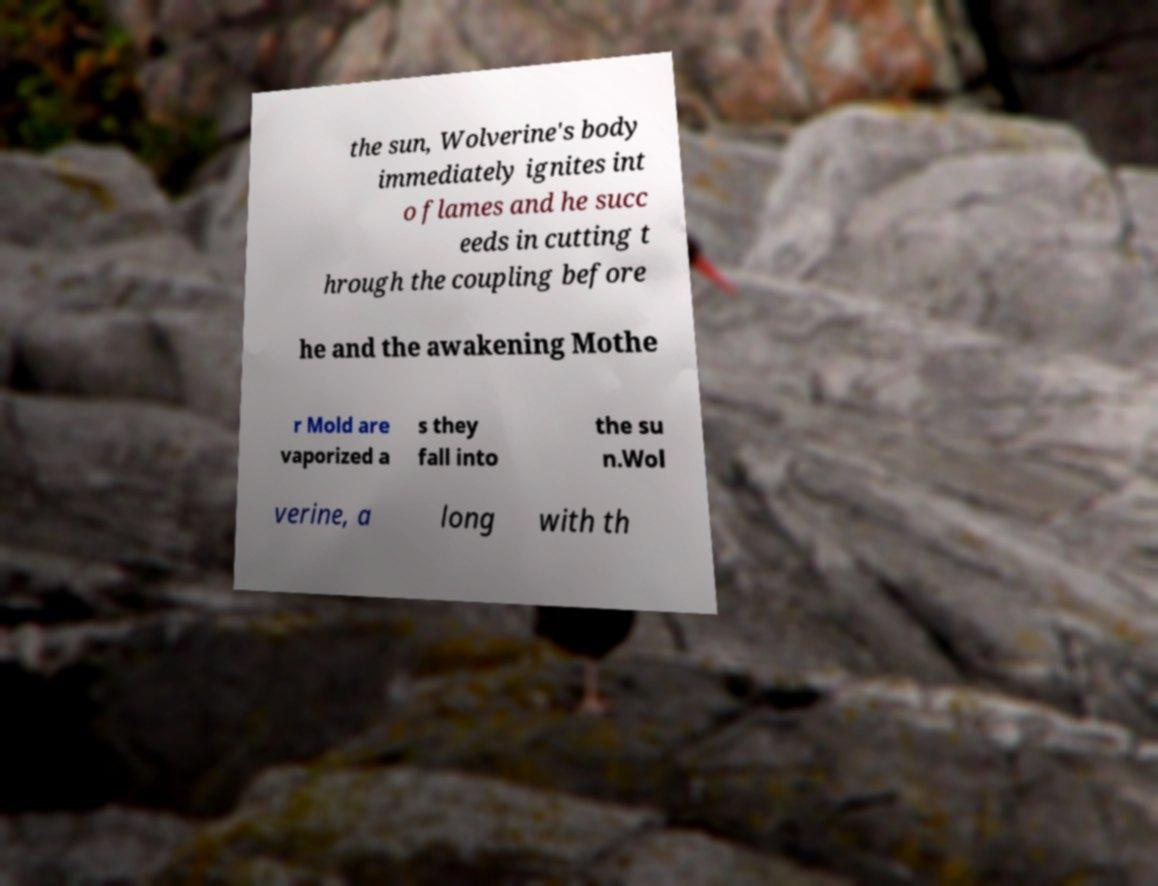For documentation purposes, I need the text within this image transcribed. Could you provide that? the sun, Wolverine's body immediately ignites int o flames and he succ eeds in cutting t hrough the coupling before he and the awakening Mothe r Mold are vaporized a s they fall into the su n.Wol verine, a long with th 